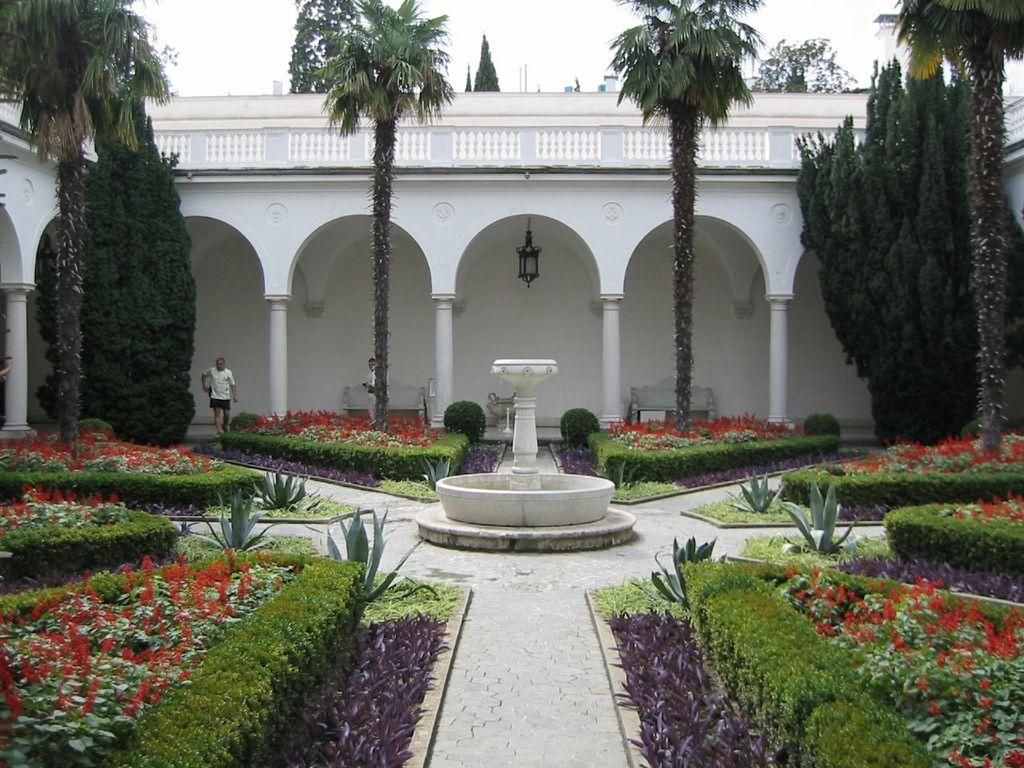What type of plants can be seen in the image? There are flower plants in the image. What is located at the center of the image? There is a fountain at the center of the image. How many people are present in the image? There are 2 people present in the image. What can be seen in the background of the image? There is a white building in the background of the image. What architectural features does the building have? The building has pillars and benches. What type of locket is hanging from the fountain in the image? There is no locket present in the image; it features a fountain, flower plants, and a white building with pillars and benches. Can you describe the veins of the flower plants in the image? There is no mention of the veins of the flower plants in the provided facts, so it cannot be determined from the image. 